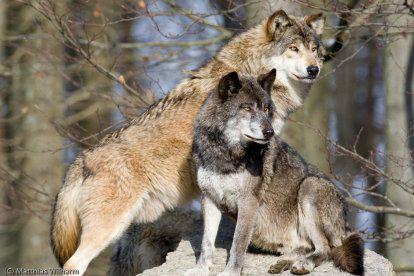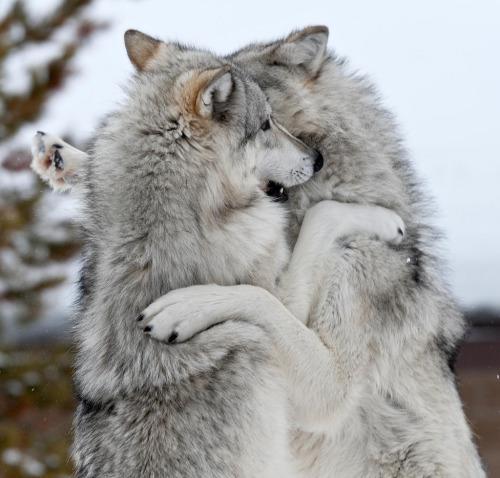The first image is the image on the left, the second image is the image on the right. Examine the images to the left and right. Is the description "There are more than one animal in the image on the left." accurate? Answer yes or no. Yes. 